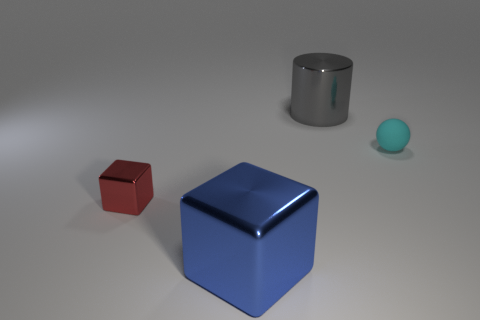What is the material of the tiny cyan ball?
Keep it short and to the point. Rubber. What number of tiny things are red matte spheres or cyan balls?
Keep it short and to the point. 1. There is a matte sphere; what number of red objects are on the left side of it?
Your answer should be very brief. 1. There is another thing that is the same size as the red object; what is its shape?
Your answer should be very brief. Sphere. How many cyan things are big cylinders or blocks?
Make the answer very short. 0. What number of cyan rubber objects have the same size as the gray thing?
Your answer should be very brief. 0. How many things are either rubber spheres or small objects that are on the right side of the gray metal cylinder?
Provide a succinct answer. 1. Does the object on the right side of the large cylinder have the same size as the blue block that is on the left side of the big gray metallic cylinder?
Provide a short and direct response. No. What number of other small cyan things are the same shape as the tiny rubber thing?
Offer a very short reply. 0. The red thing that is the same material as the gray object is what shape?
Keep it short and to the point. Cube. 